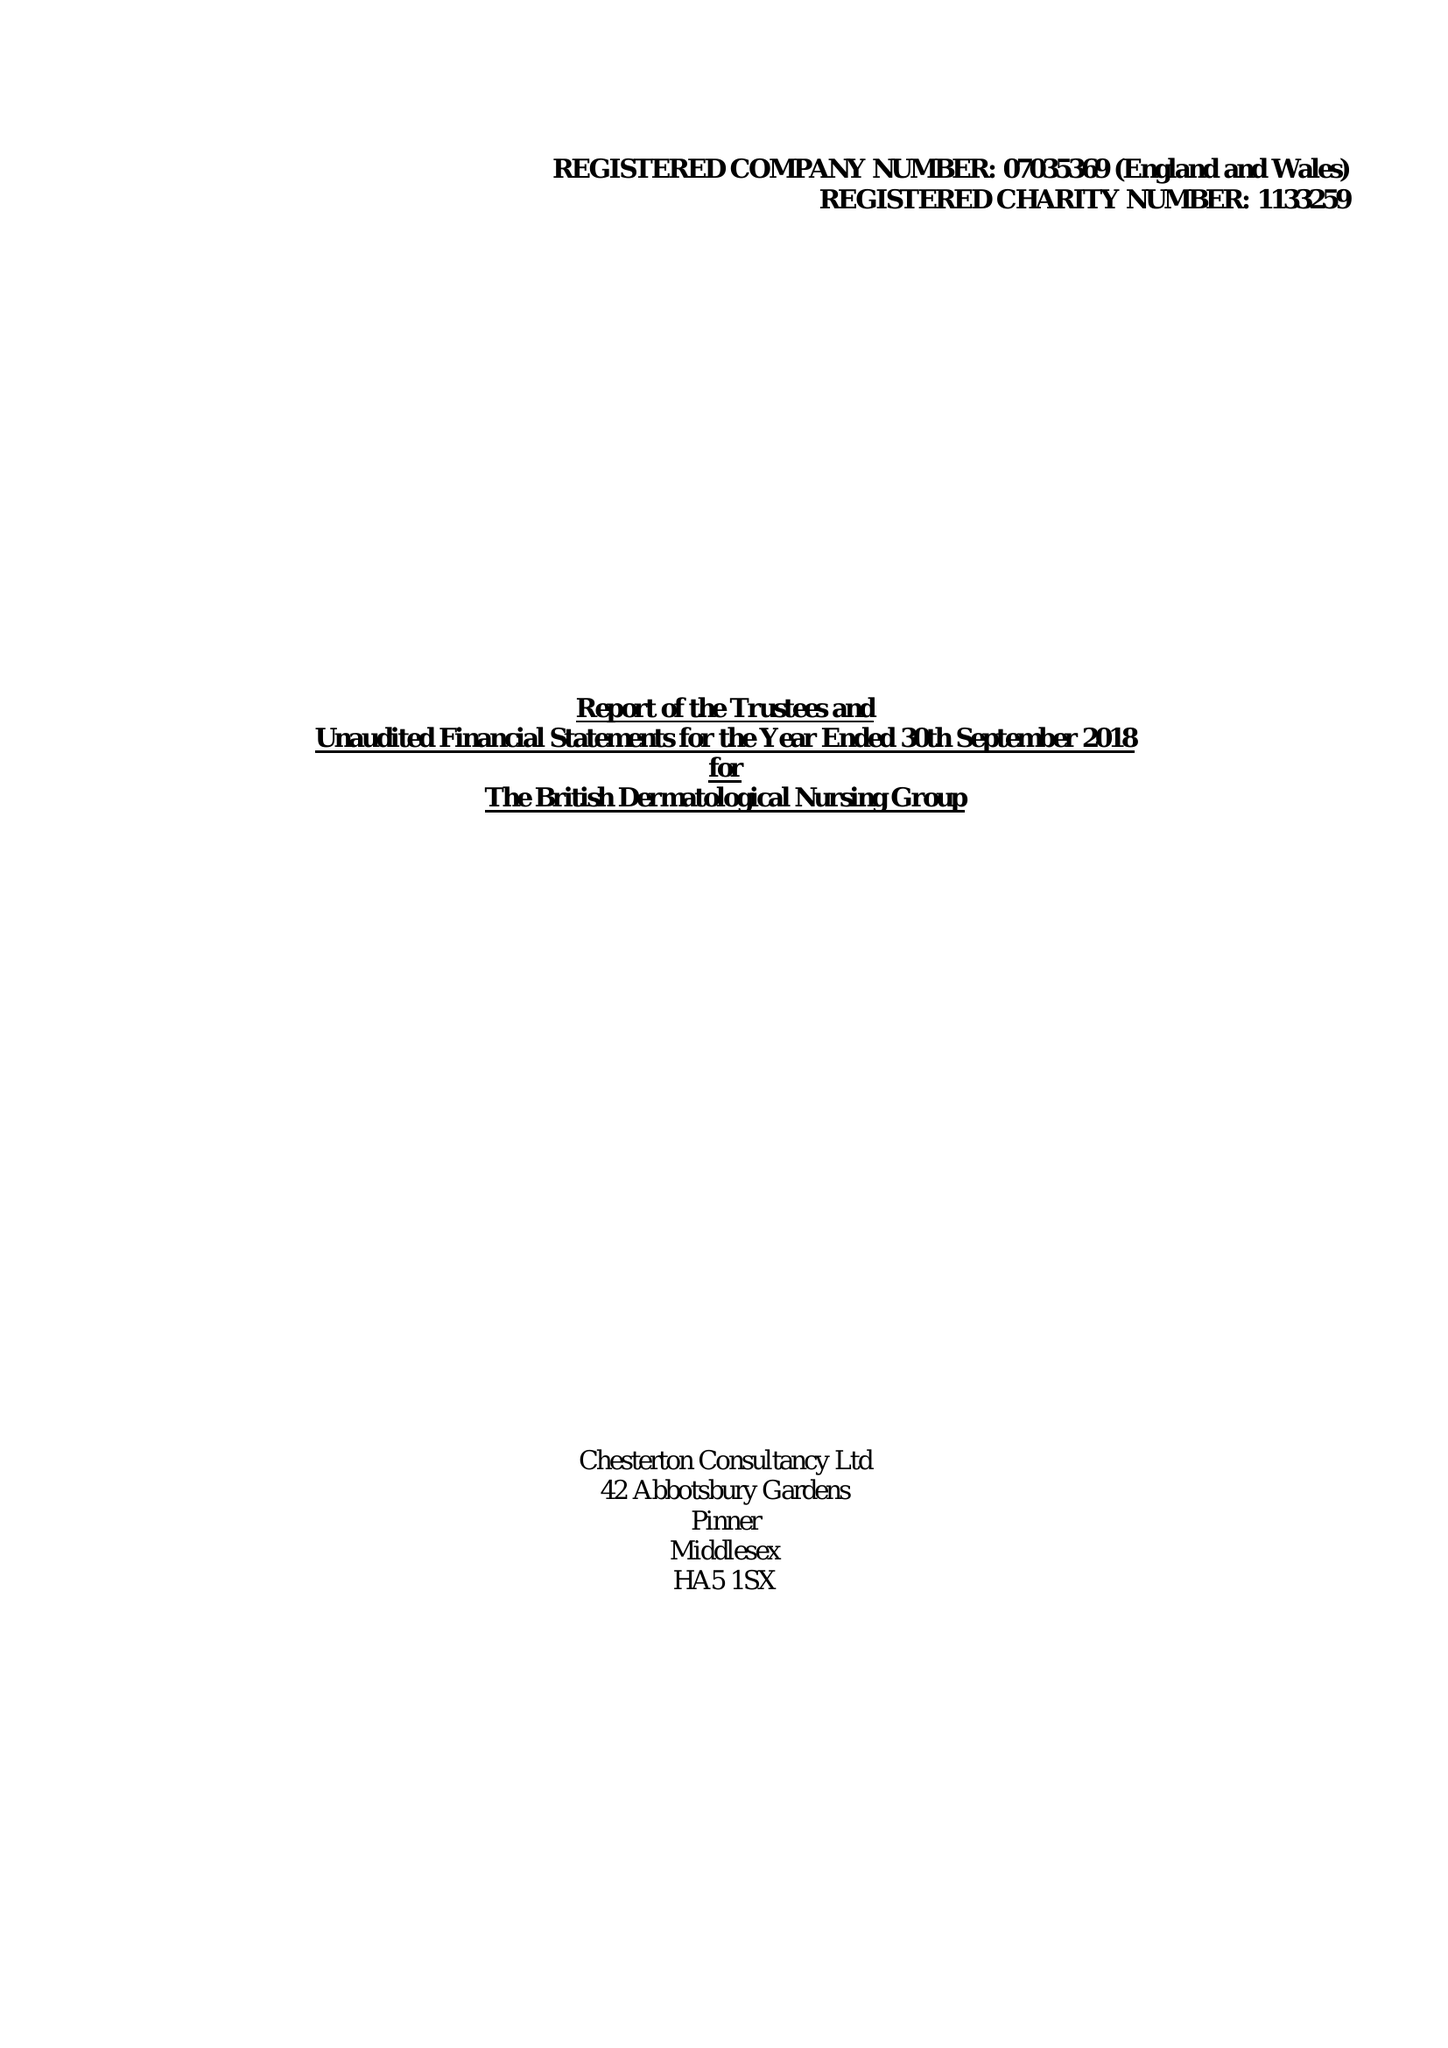What is the value for the address__postcode?
Answer the question using a single word or phrase. WC1V 7QT 